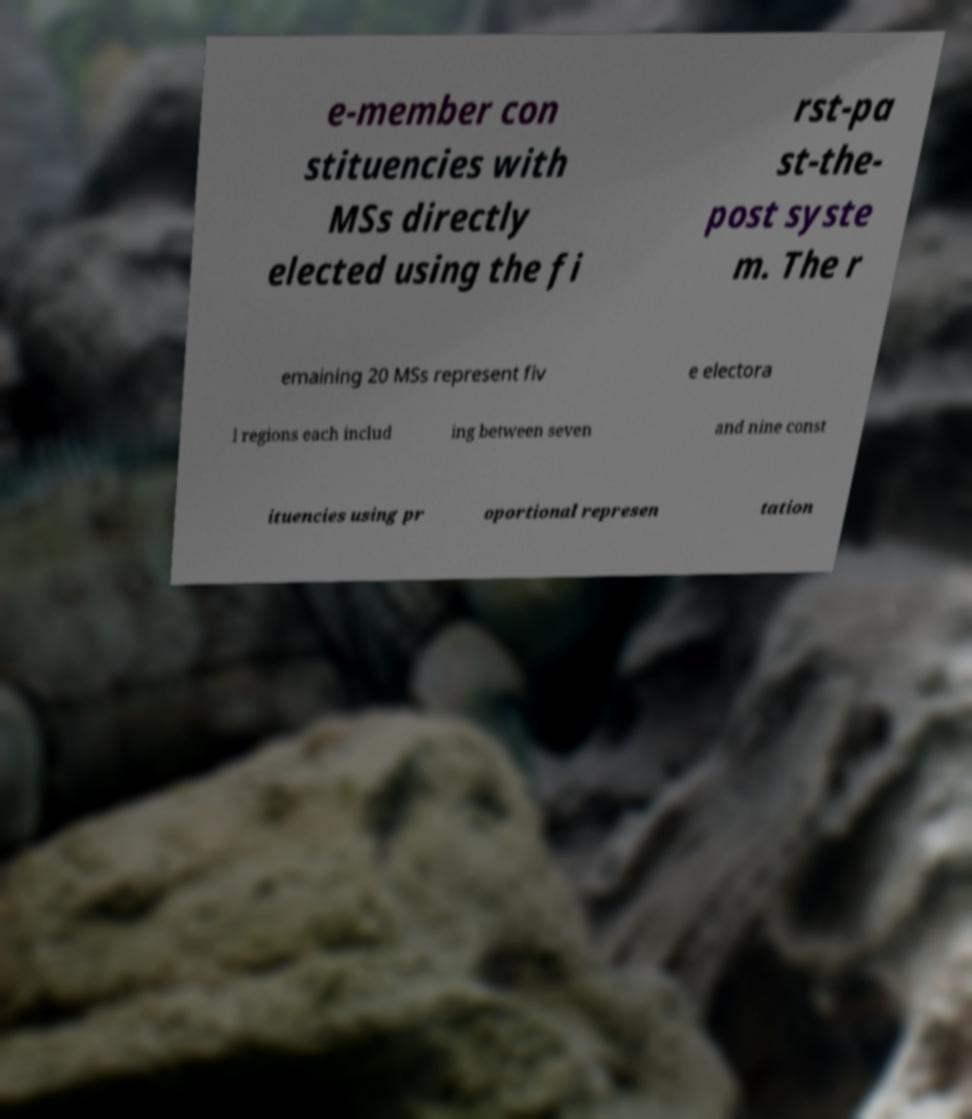Could you assist in decoding the text presented in this image and type it out clearly? e-member con stituencies with MSs directly elected using the fi rst-pa st-the- post syste m. The r emaining 20 MSs represent fiv e electora l regions each includ ing between seven and nine const ituencies using pr oportional represen tation 